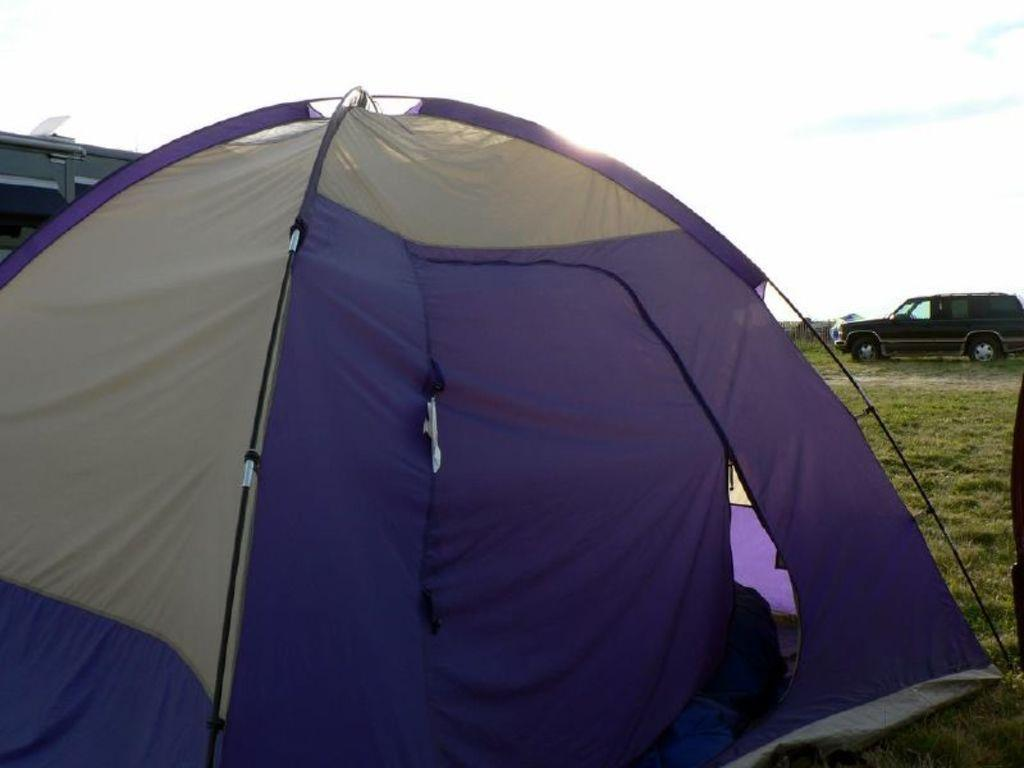What structure can be seen in the image? There is a tent in the image. What can be seen in the distance behind the tent? There is a building and a car in the background of the image. What type of vegetation is visible in the background? Grass is present in the background of the image. What type of nerve can be seen in the image? There are no nerves present in the image; it features a tent, a building, a car, and grass. What kind of paste is being used to hold the tent together in the image? There is no indication of any paste being used to hold the tent together in the image. 